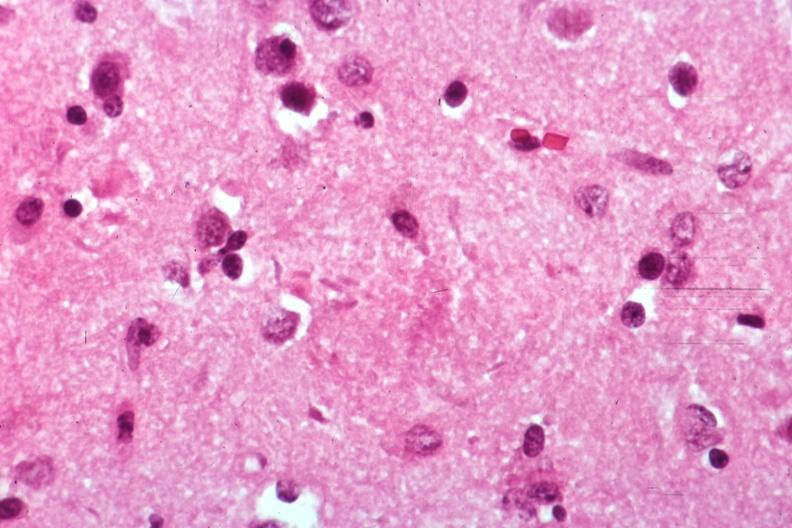s brain present?
Answer the question using a single word or phrase. Yes 